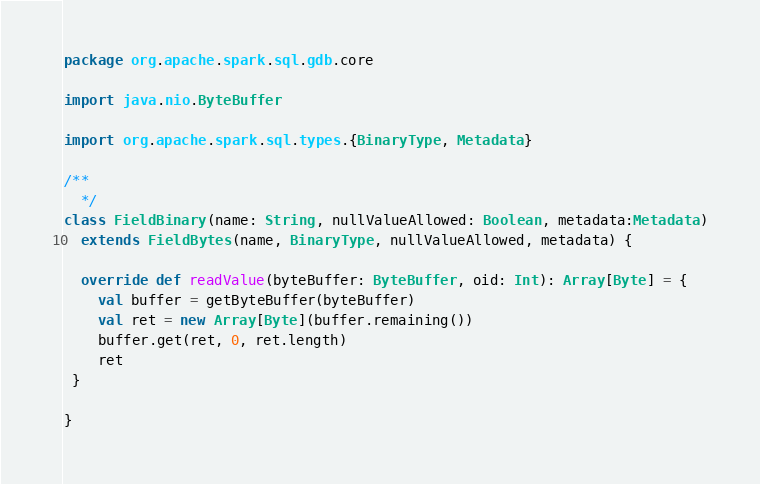<code> <loc_0><loc_0><loc_500><loc_500><_Scala_>package org.apache.spark.sql.gdb.core

import java.nio.ByteBuffer

import org.apache.spark.sql.types.{BinaryType, Metadata}

/**
  */
class FieldBinary(name: String, nullValueAllowed: Boolean, metadata:Metadata)
  extends FieldBytes(name, BinaryType, nullValueAllowed, metadata) {

  override def readValue(byteBuffer: ByteBuffer, oid: Int): Array[Byte] = {
    val buffer = getByteBuffer(byteBuffer)
    val ret = new Array[Byte](buffer.remaining())
    buffer.get(ret, 0, ret.length)
    ret
 }

}
</code> 